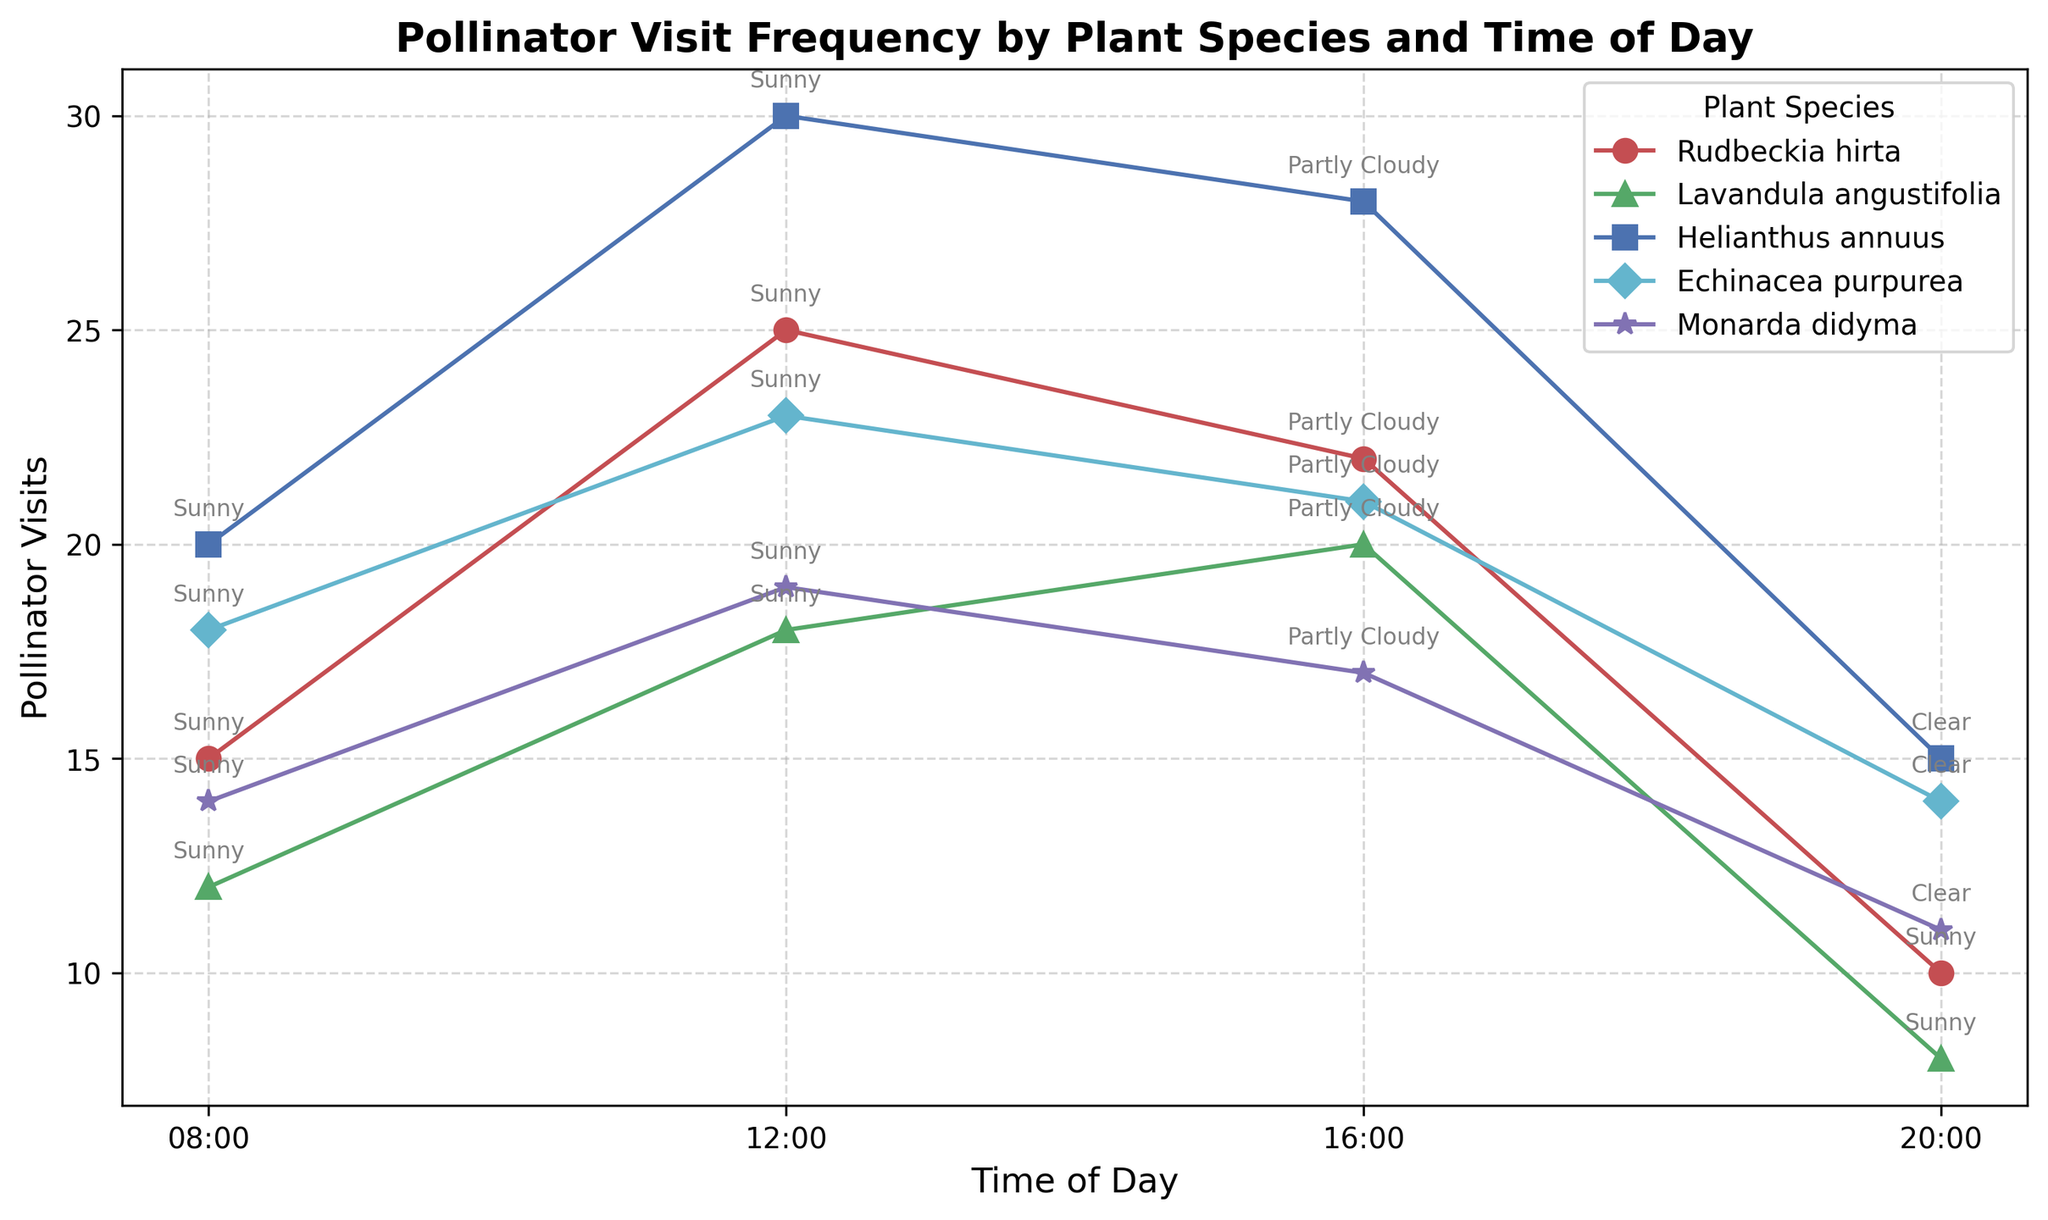What plant species has the highest number of pollinator visits at 12:00? To answer this, look at the markers corresponding to 12:00 for all the plant species in the figure and compare their values. Helianthus annuus shows the highest number of pollinator visits at 12:00.
Answer: Helianthus annuus Which time of day has the most pollinator visits for Lavandula angustifolia? Examine the data points for Lavandula angustifolia across all times of the day and identify the time with the highest value. The number of pollinator visits is highest at 16:00 for Lavandula angustifolia.
Answer: 16:00 Do pollinator visits for Helianthus annuus increase or decrease from 08:00 to 20:00? Observe the polyline connecting the pollinator visits for Helianthus annuus at different times. The visits increase from 08:00 to 12:00, then slightly decrease at 16:00, and further decrease at 20:00.
Answer: Decrease Which plant species has the lowest number of pollinator visits at 20:00? Compare all the species' points marked at 20:00 and find the one with the lowest value. Lavandula angustifolia has the lowest number of pollinator visits at 20:00.
Answer: Lavandula angustifolia Is there any plant species for which pollinator visits are consistently decreasing throughout the day? Check each plant species' progression of pollinator visits from 08:00 to 20:00 to see if there is a consistent downward trend. None of the plant species show a consistently decreasing trend throughout the day.
Answer: No How many more pollinator visits does Rudbeckia hirta receive at 12:00 compared to 08:00? Subtract the number of pollinator visits at 08:00 from those at 12:00 for Rudbeckia hirta. It receives 25 visits at 12:00 and 15 at 08:00, so the difference is 25 - 15.
Answer: 10 Which weather condition is associated with the highest number of pollinator visits for Echinacea purpurea? Check the annotations corresponding to the highest pollinator visit point for Echinacea purpurea. The highest visits occur at 12:00 under sunny conditions.
Answer: Sunny Compare the pollinator visits between 08:00 and 20:00 for Monarda didyma and identify which time has higher visits and by how much. Check the pollinator visit counts for Monarda didyma at both times. It receives 14 visits at 08:00 and 11 at 20:00. Therefore, 08:00 has higher visits by 14 - 11.
Answer: 08:00 by 3 What is the range of pollinator visits for Helianthus annuus throughout the day? Identify the maximum and minimum pollinator visits for Helianthus annuus at different times and calculate the range. The maximum is 30 (at 12:00) and the minimum is 15 (at 20:00). The range is 30 - 15.
Answer: 15 Compare the patterns of pollinator visits for Rudbeckia hirta and Monarda didyma. How do their trends from 08:00 to 20:00 differ? Examine the plots for both species from 08:00 to 20:00. For Rudbeckia hirta, visits increase from 08:00 to 12:00, slightly decrease at 16:00, and significantly drop at 20:00. For Monarda didyma, visits follow a similar increase to 12:00, decrease at 16:00, and drop at 20:00.
Answer: Rudbeckia increases more sharply and decreases more at 20:00 